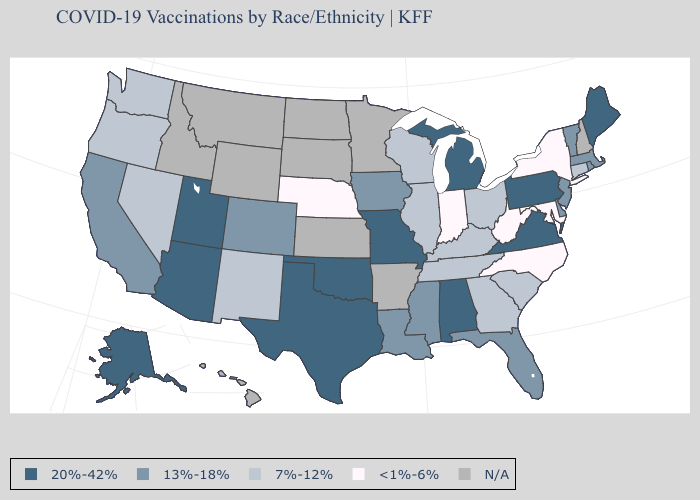What is the value of New Hampshire?
Quick response, please. N/A. What is the lowest value in the MidWest?
Answer briefly. <1%-6%. What is the value of Minnesota?
Concise answer only. N/A. Among the states that border Vermont , which have the highest value?
Keep it brief. Massachusetts. Does California have the lowest value in the USA?
Keep it brief. No. Name the states that have a value in the range 13%-18%?
Answer briefly. California, Colorado, Delaware, Florida, Iowa, Louisiana, Massachusetts, Mississippi, New Jersey, Rhode Island, Vermont. Is the legend a continuous bar?
Answer briefly. No. What is the value of Maine?
Be succinct. 20%-42%. Name the states that have a value in the range N/A?
Keep it brief. Arkansas, Hawaii, Idaho, Kansas, Minnesota, Montana, New Hampshire, North Dakota, South Dakota, Wyoming. Name the states that have a value in the range 13%-18%?
Short answer required. California, Colorado, Delaware, Florida, Iowa, Louisiana, Massachusetts, Mississippi, New Jersey, Rhode Island, Vermont. Name the states that have a value in the range 13%-18%?
Write a very short answer. California, Colorado, Delaware, Florida, Iowa, Louisiana, Massachusetts, Mississippi, New Jersey, Rhode Island, Vermont. Name the states that have a value in the range 20%-42%?
Keep it brief. Alabama, Alaska, Arizona, Maine, Michigan, Missouri, Oklahoma, Pennsylvania, Texas, Utah, Virginia. What is the lowest value in states that border Kentucky?
Be succinct. <1%-6%. What is the highest value in states that border Colorado?
Concise answer only. 20%-42%. Which states hav the highest value in the MidWest?
Give a very brief answer. Michigan, Missouri. 